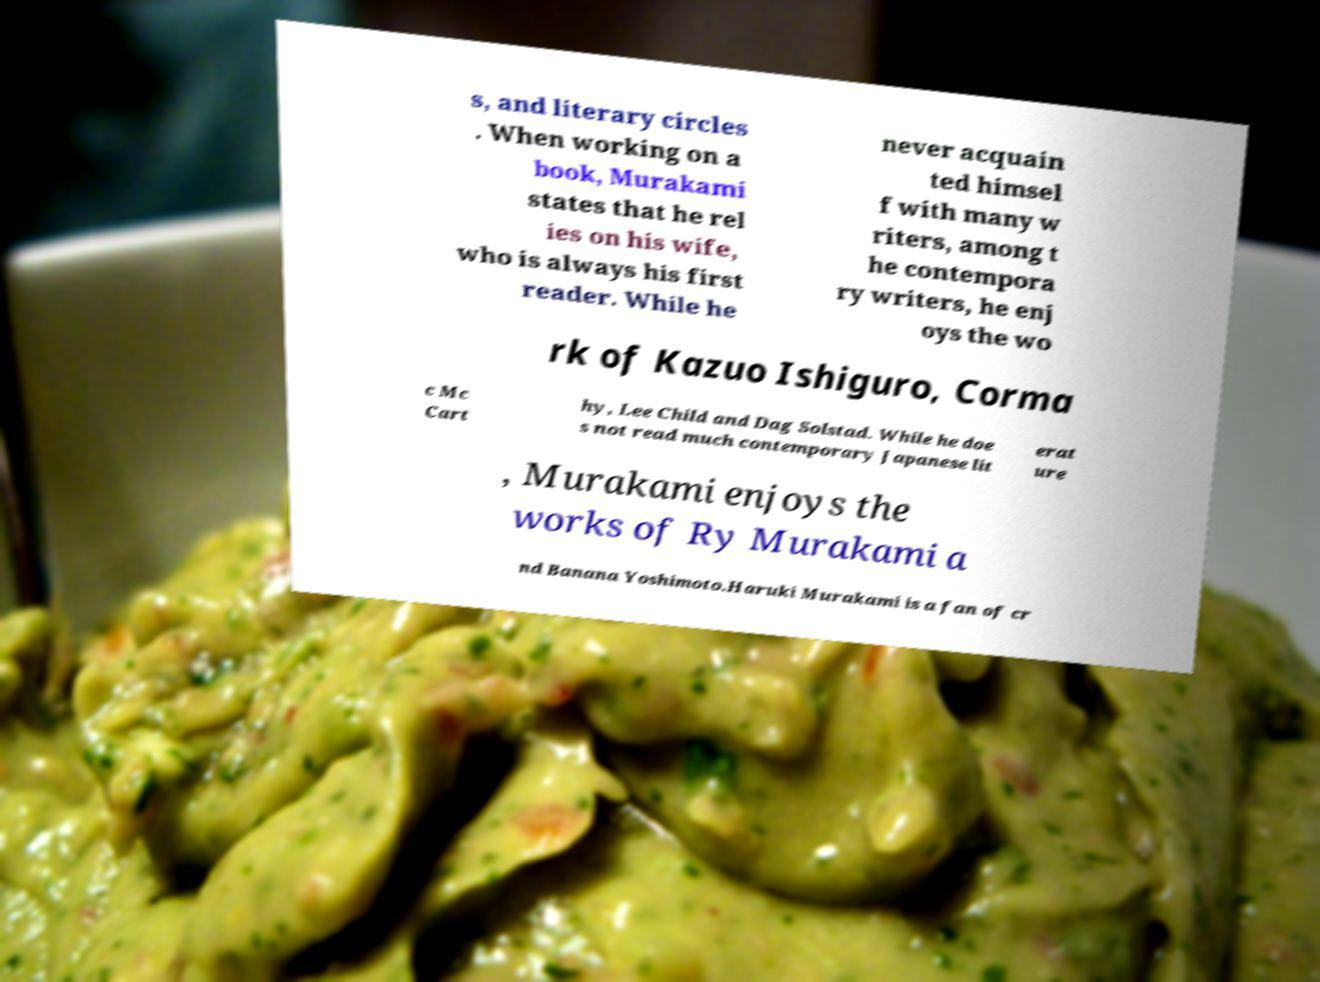Please identify and transcribe the text found in this image. s, and literary circles . When working on a book, Murakami states that he rel ies on his wife, who is always his first reader. While he never acquain ted himsel f with many w riters, among t he contempora ry writers, he enj oys the wo rk of Kazuo Ishiguro, Corma c Mc Cart hy, Lee Child and Dag Solstad. While he doe s not read much contemporary Japanese lit erat ure , Murakami enjoys the works of Ry Murakami a nd Banana Yoshimoto.Haruki Murakami is a fan of cr 